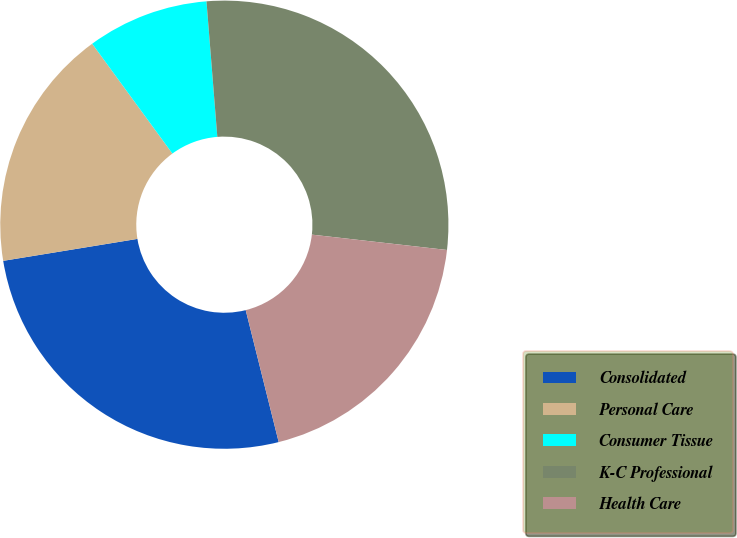Convert chart to OTSL. <chart><loc_0><loc_0><loc_500><loc_500><pie_chart><fcel>Consolidated<fcel>Personal Care<fcel>Consumer Tissue<fcel>K-C Professional<fcel>Health Care<nl><fcel>26.32%<fcel>17.54%<fcel>8.77%<fcel>28.07%<fcel>19.3%<nl></chart> 